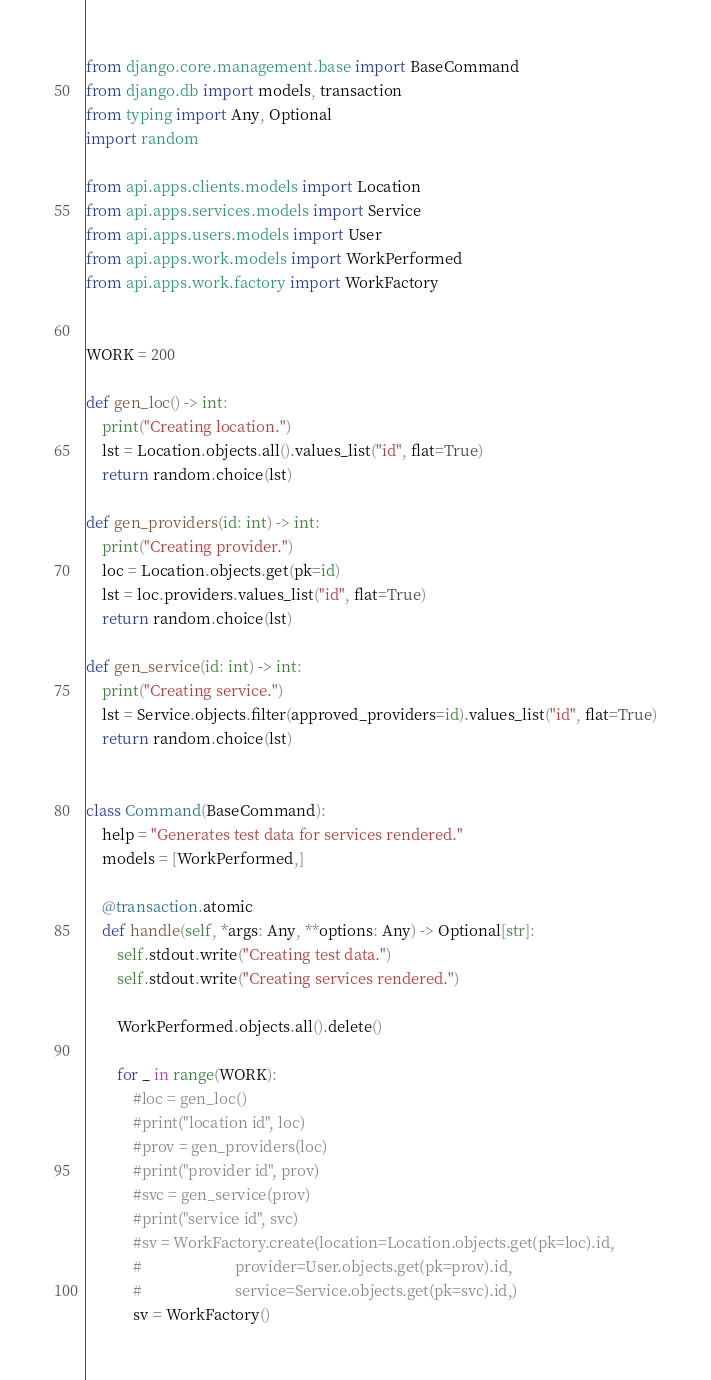Convert code to text. <code><loc_0><loc_0><loc_500><loc_500><_Python_>from django.core.management.base import BaseCommand
from django.db import models, transaction
from typing import Any, Optional
import random

from api.apps.clients.models import Location
from api.apps.services.models import Service
from api.apps.users.models import User
from api.apps.work.models import WorkPerformed
from api.apps.work.factory import WorkFactory


WORK = 200

def gen_loc() -> int:
    print("Creating location.")
    lst = Location.objects.all().values_list("id", flat=True)
    return random.choice(lst)

def gen_providers(id: int) -> int:
    print("Creating provider.")
    loc = Location.objects.get(pk=id)
    lst = loc.providers.values_list("id", flat=True)
    return random.choice(lst)

def gen_service(id: int) -> int:
    print("Creating service.")
    lst = Service.objects.filter(approved_providers=id).values_list("id", flat=True)
    return random.choice(lst)


class Command(BaseCommand):
    help = "Generates test data for services rendered."
    models = [WorkPerformed,]

    @transaction.atomic
    def handle(self, *args: Any, **options: Any) -> Optional[str]:
        self.stdout.write("Creating test data.")
        self.stdout.write("Creating services rendered.")

        WorkPerformed.objects.all().delete()

        for _ in range(WORK):
            #loc = gen_loc()
            #print("location id", loc)
            #prov = gen_providers(loc)
            #print("provider id", prov)
            #svc = gen_service(prov)
            #print("service id", svc)
            #sv = WorkFactory.create(location=Location.objects.get(pk=loc).id,
            #                        provider=User.objects.get(pk=prov).id,
            #                        service=Service.objects.get(pk=svc).id,)
            sv = WorkFactory()</code> 